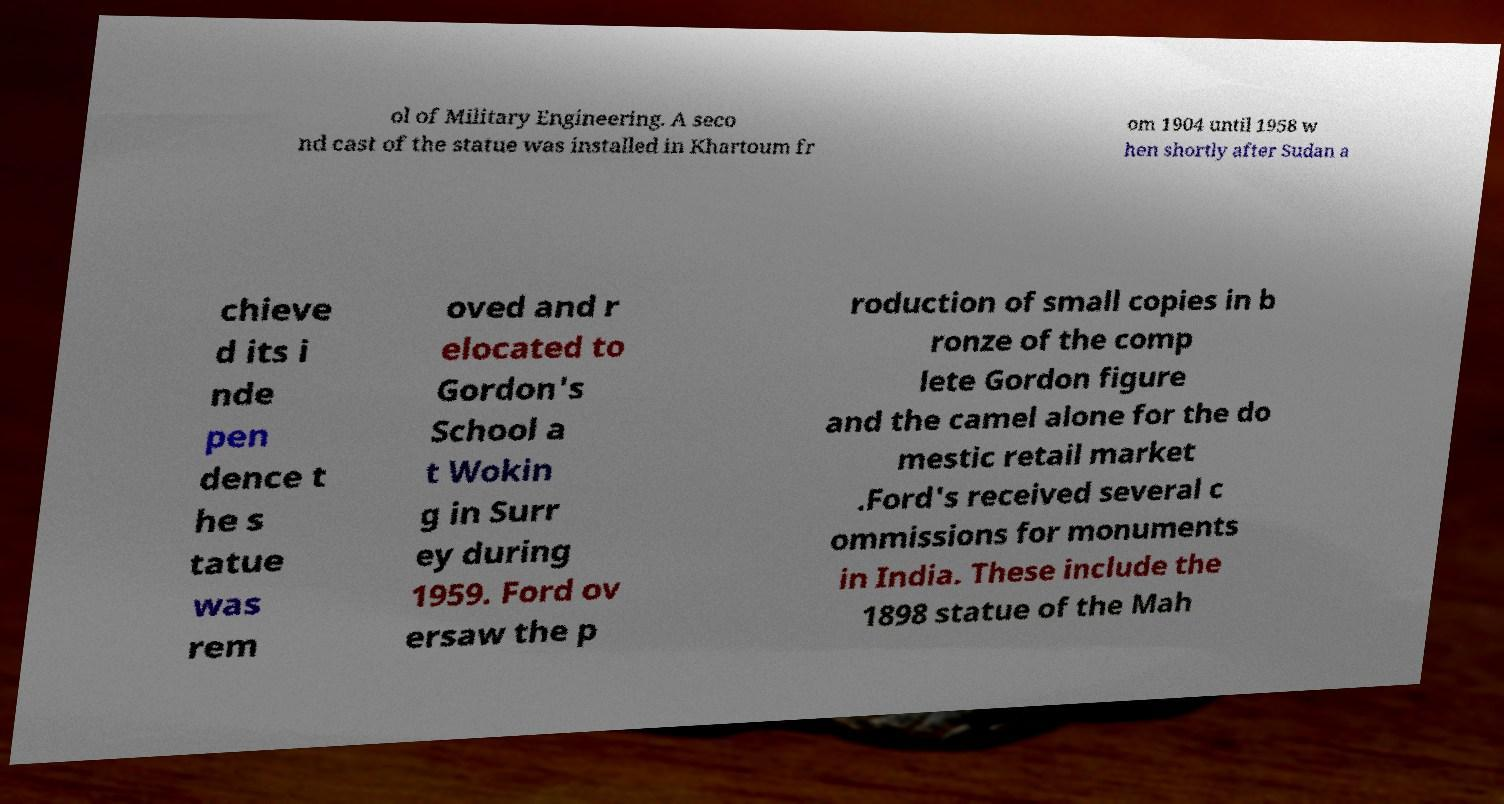Can you read and provide the text displayed in the image?This photo seems to have some interesting text. Can you extract and type it out for me? ol of Military Engineering. A seco nd cast of the statue was installed in Khartoum fr om 1904 until 1958 w hen shortly after Sudan a chieve d its i nde pen dence t he s tatue was rem oved and r elocated to Gordon's School a t Wokin g in Surr ey during 1959. Ford ov ersaw the p roduction of small copies in b ronze of the comp lete Gordon figure and the camel alone for the do mestic retail market .Ford's received several c ommissions for monuments in India. These include the 1898 statue of the Mah 